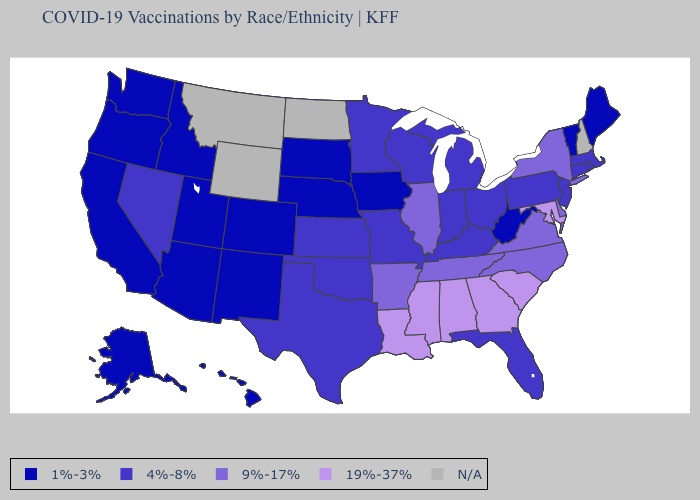What is the value of California?
Write a very short answer. 1%-3%. Does Nevada have the lowest value in the West?
Answer briefly. No. Is the legend a continuous bar?
Keep it brief. No. Name the states that have a value in the range 1%-3%?
Be succinct. Alaska, Arizona, California, Colorado, Hawaii, Idaho, Iowa, Maine, Nebraska, New Mexico, Oregon, South Dakota, Utah, Vermont, Washington, West Virginia. What is the value of Minnesota?
Keep it brief. 4%-8%. Which states have the lowest value in the USA?
Be succinct. Alaska, Arizona, California, Colorado, Hawaii, Idaho, Iowa, Maine, Nebraska, New Mexico, Oregon, South Dakota, Utah, Vermont, Washington, West Virginia. Name the states that have a value in the range 9%-17%?
Concise answer only. Arkansas, Delaware, Illinois, New York, North Carolina, Tennessee, Virginia. Does the first symbol in the legend represent the smallest category?
Quick response, please. Yes. Name the states that have a value in the range N/A?
Be succinct. Montana, New Hampshire, North Dakota, Wyoming. What is the value of Delaware?
Be succinct. 9%-17%. Does South Carolina have the highest value in the USA?
Give a very brief answer. Yes. Name the states that have a value in the range 9%-17%?
Write a very short answer. Arkansas, Delaware, Illinois, New York, North Carolina, Tennessee, Virginia. Name the states that have a value in the range 19%-37%?
Write a very short answer. Alabama, Georgia, Louisiana, Maryland, Mississippi, South Carolina. 